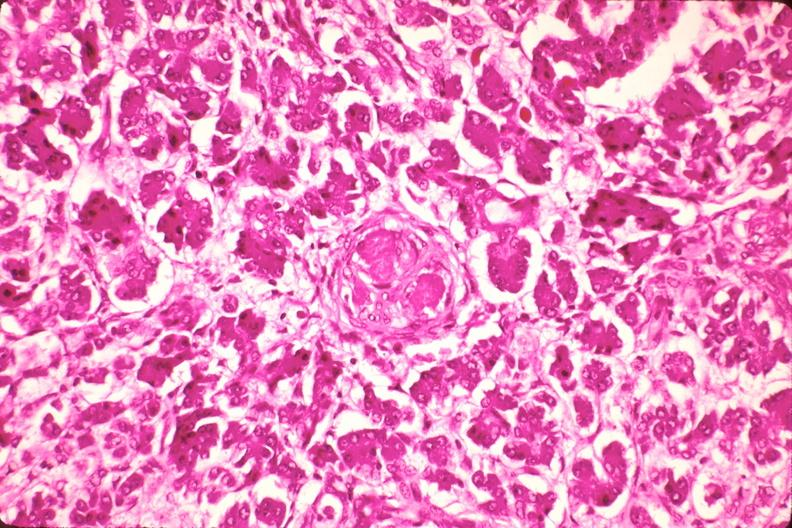what is present?
Answer the question using a single word or phrase. Endocrine 